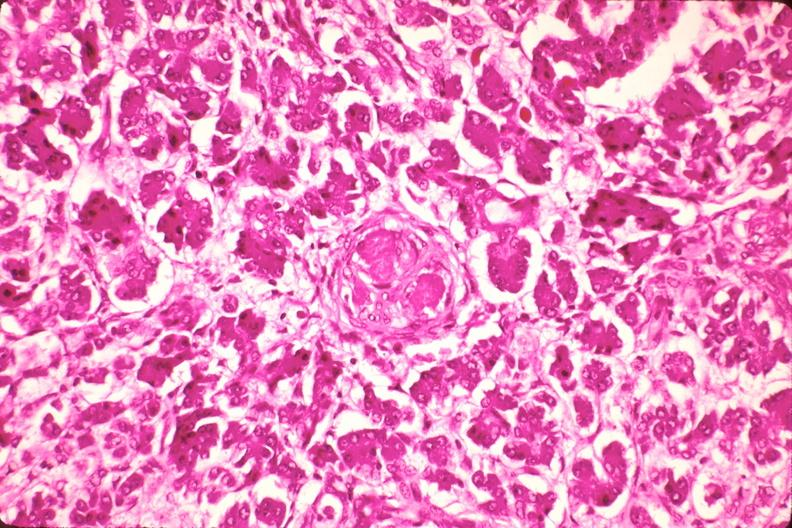what is present?
Answer the question using a single word or phrase. Endocrine 